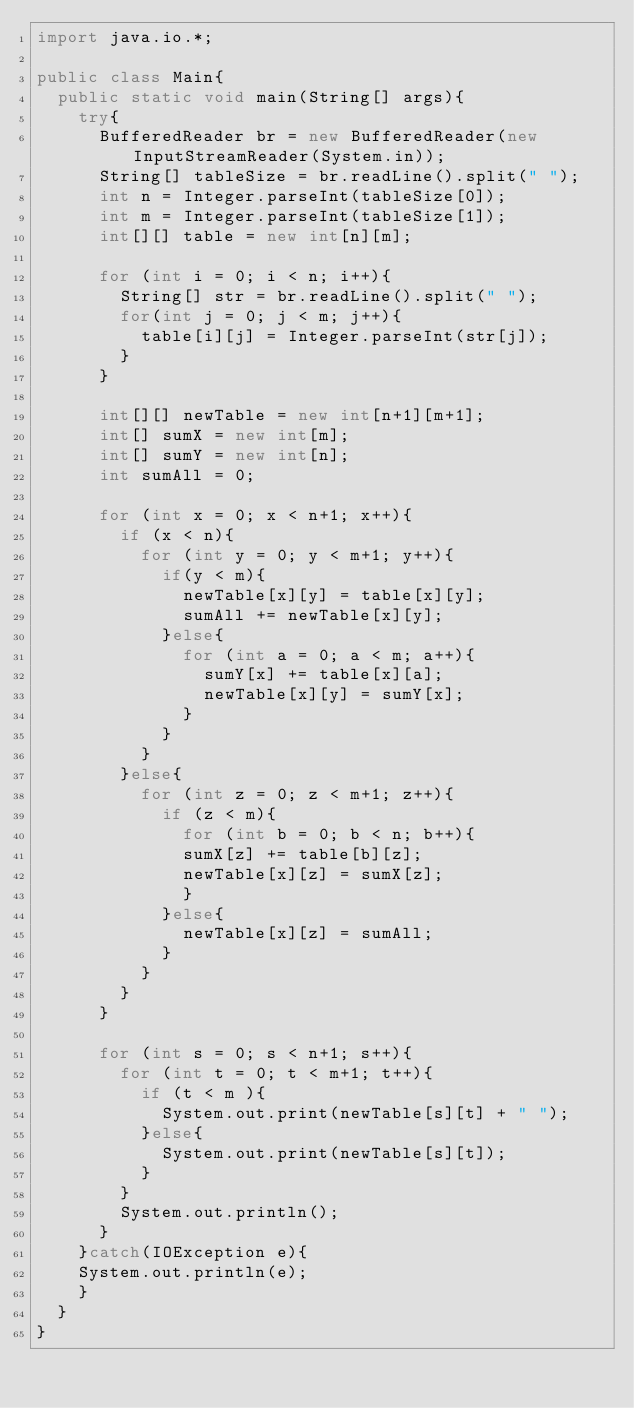Convert code to text. <code><loc_0><loc_0><loc_500><loc_500><_Java_>import java.io.*;

public class Main{
	public static void main(String[] args){
		try{
			BufferedReader br = new BufferedReader(new InputStreamReader(System.in));
			String[] tableSize = br.readLine().split(" ");
			int n = Integer.parseInt(tableSize[0]);
			int m = Integer.parseInt(tableSize[1]);
			int[][] table = new int[n][m];

			for (int i = 0; i < n; i++){
				String[] str = br.readLine().split(" ");
				for(int j = 0; j < m; j++){
					table[i][j] = Integer.parseInt(str[j]);
				}
			}

			int[][] newTable = new int[n+1][m+1];
			int[] sumX = new int[m];
			int[] sumY = new int[n];
			int sumAll = 0;

			for (int x = 0; x < n+1; x++){
				if (x < n){
					for (int y = 0; y < m+1; y++){
						if(y < m){
							newTable[x][y] = table[x][y];
							sumAll += newTable[x][y];
						}else{
							for (int a = 0; a < m; a++){
								sumY[x] += table[x][a];
								newTable[x][y] = sumY[x];
							}
						}
					}
				}else{
					for (int z = 0; z < m+1; z++){
						if (z < m){
							for (int b = 0; b < n; b++){
							sumX[z] += table[b][z];
							newTable[x][z] = sumX[z];
							}
						}else{
							newTable[x][z] = sumAll;
						}
					}
				}
			}

			for (int s = 0; s < n+1; s++){
				for (int t = 0; t < m+1; t++){
					if (t < m ){
						System.out.print(newTable[s][t] + " ");
					}else{
						System.out.print(newTable[s][t]);
					}
				}
				System.out.println();
			}
		}catch(IOException e){
		System.out.println(e);
		}
	}
}</code> 